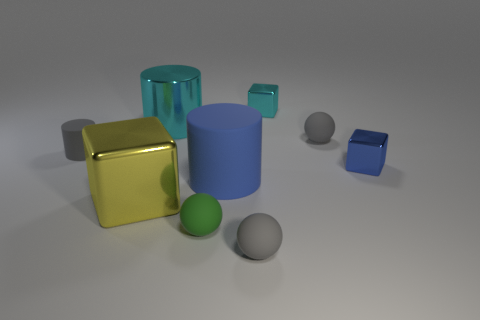What is the size of the thing that is behind the big blue rubber object and on the left side of the big cyan metallic cylinder?
Your answer should be compact. Small. What material is the big thing behind the blue thing that is behind the big cylinder to the right of the cyan shiny cylinder?
Provide a short and direct response. Metal. There is a tiny thing that is the same color as the large rubber cylinder; what material is it?
Keep it short and to the point. Metal. There is a small object in front of the small green sphere; is it the same color as the tiny object that is left of the cyan cylinder?
Provide a succinct answer. Yes. What is the shape of the big metallic thing that is behind the gray matte object that is behind the tiny gray rubber thing to the left of the large cyan shiny thing?
Your answer should be very brief. Cylinder. The rubber thing that is both on the right side of the green rubber ball and behind the tiny blue metallic block has what shape?
Ensure brevity in your answer.  Sphere. There is a big matte thing in front of the small metallic object that is behind the blue block; what number of cyan metallic cylinders are behind it?
Offer a terse response. 1. What is the size of the other matte object that is the same shape as the blue rubber object?
Offer a very short reply. Small. Does the blue thing in front of the blue metal cube have the same material as the small blue thing?
Provide a succinct answer. No. What is the color of the other small metallic thing that is the same shape as the tiny cyan metal thing?
Provide a succinct answer. Blue. 